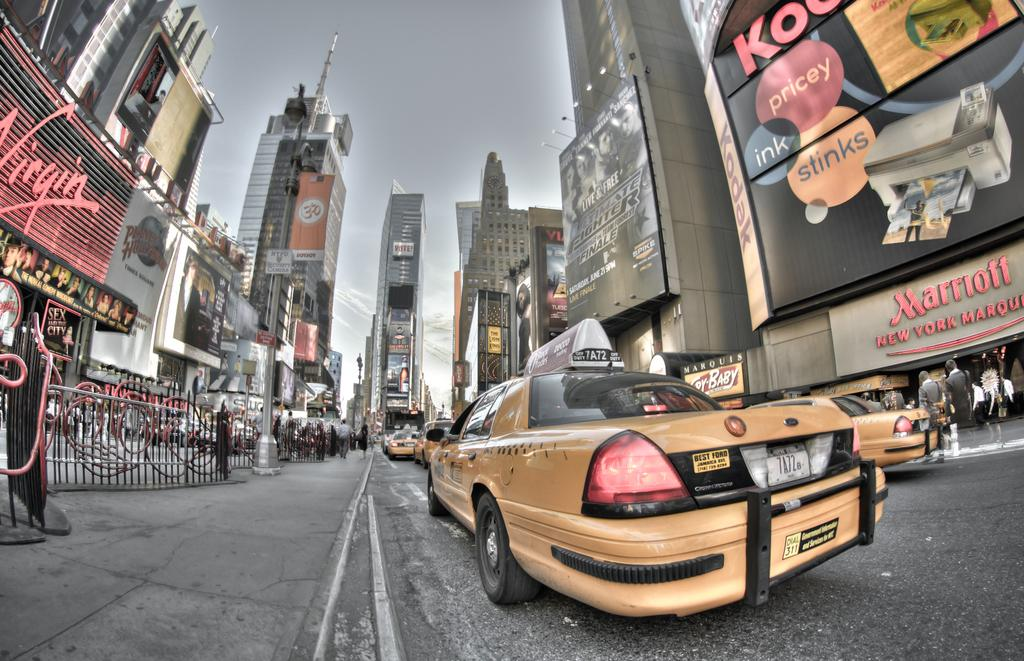<image>
Describe the image concisely. A street full of yellow taxis are out front of a building that says Marriott New York Marque. 